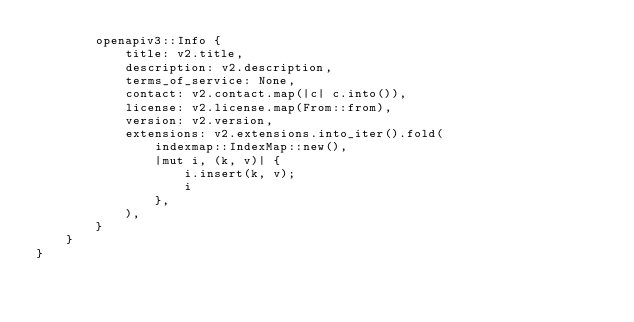<code> <loc_0><loc_0><loc_500><loc_500><_Rust_>        openapiv3::Info {
            title: v2.title,
            description: v2.description,
            terms_of_service: None,
            contact: v2.contact.map(|c| c.into()),
            license: v2.license.map(From::from),
            version: v2.version,
            extensions: v2.extensions.into_iter().fold(
                indexmap::IndexMap::new(),
                |mut i, (k, v)| {
                    i.insert(k, v);
                    i
                },
            ),
        }
    }
}
</code> 